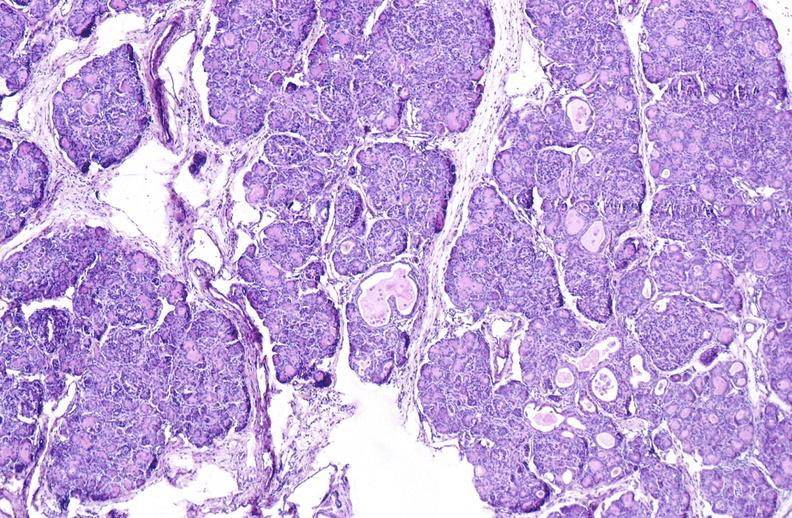what is present?
Answer the question using a single word or phrase. Pancreas 